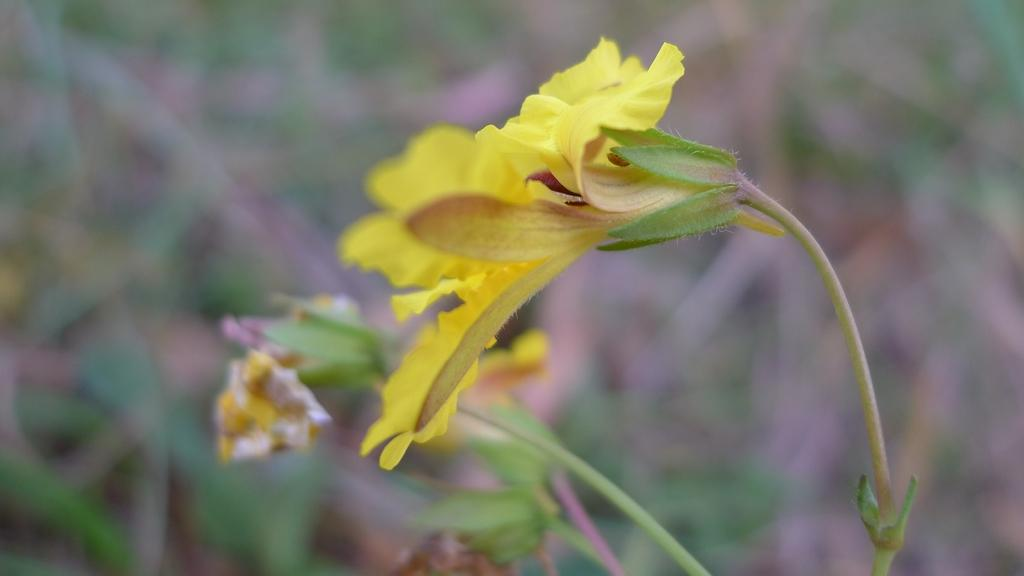What is the main subject of the image? There is a flower in the image. Can you describe the color of the flower? The flower is yellow. What else can be seen in the background of the image? There are plants in the background of the image. How is the background of the image depicted? The background is blurred. Where is the tramp located in the image? There is no tramp present in the image. What type of carriage can be seen in the background of the image? There is no carriage present in the image; it features a flower and blurred plants in the background. 